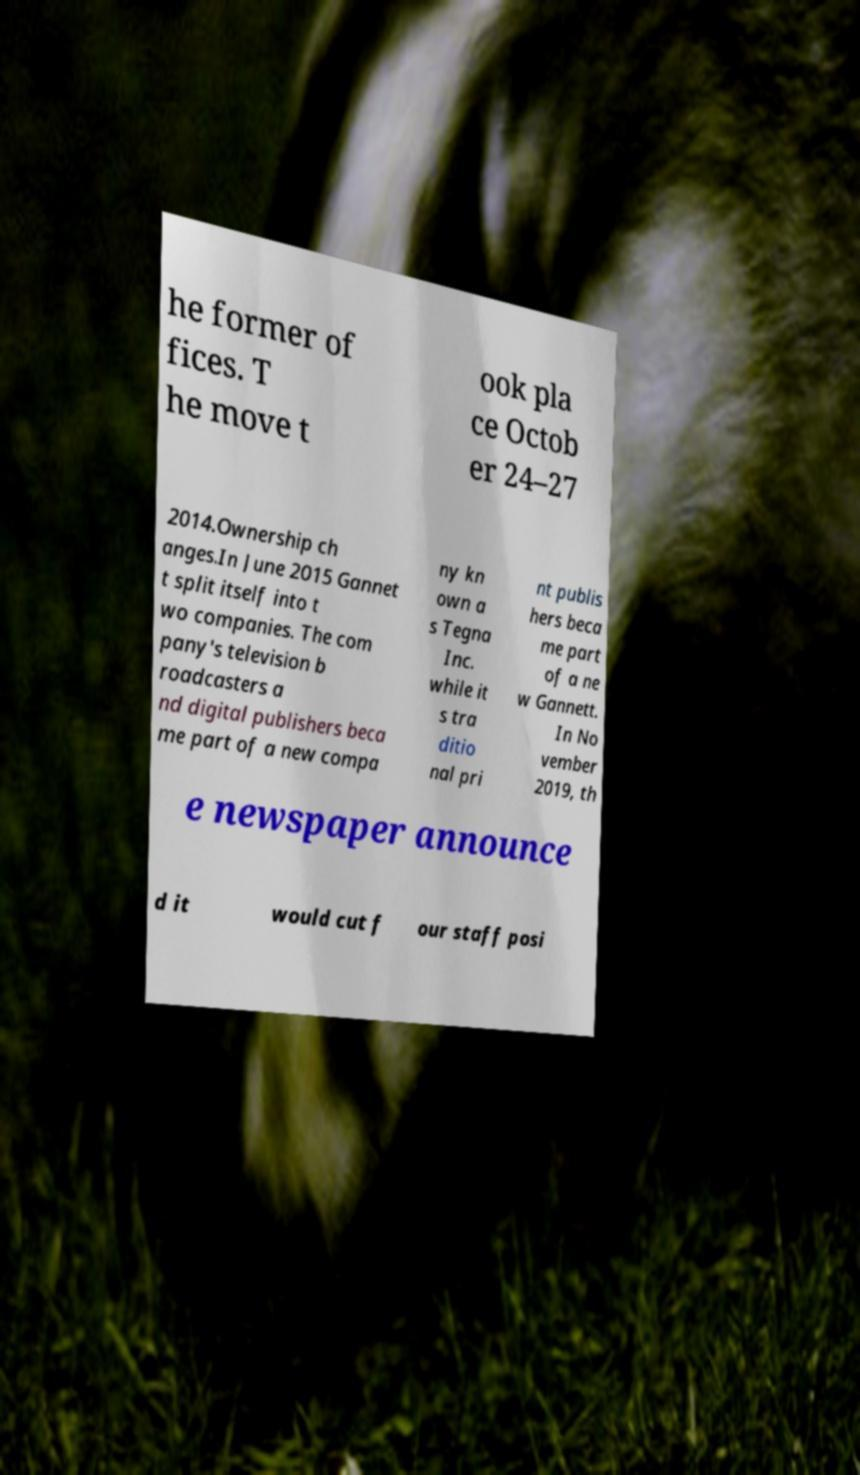For documentation purposes, I need the text within this image transcribed. Could you provide that? he former of fices. T he move t ook pla ce Octob er 24–27 2014.Ownership ch anges.In June 2015 Gannet t split itself into t wo companies. The com pany's television b roadcasters a nd digital publishers beca me part of a new compa ny kn own a s Tegna Inc. while it s tra ditio nal pri nt publis hers beca me part of a ne w Gannett. In No vember 2019, th e newspaper announce d it would cut f our staff posi 